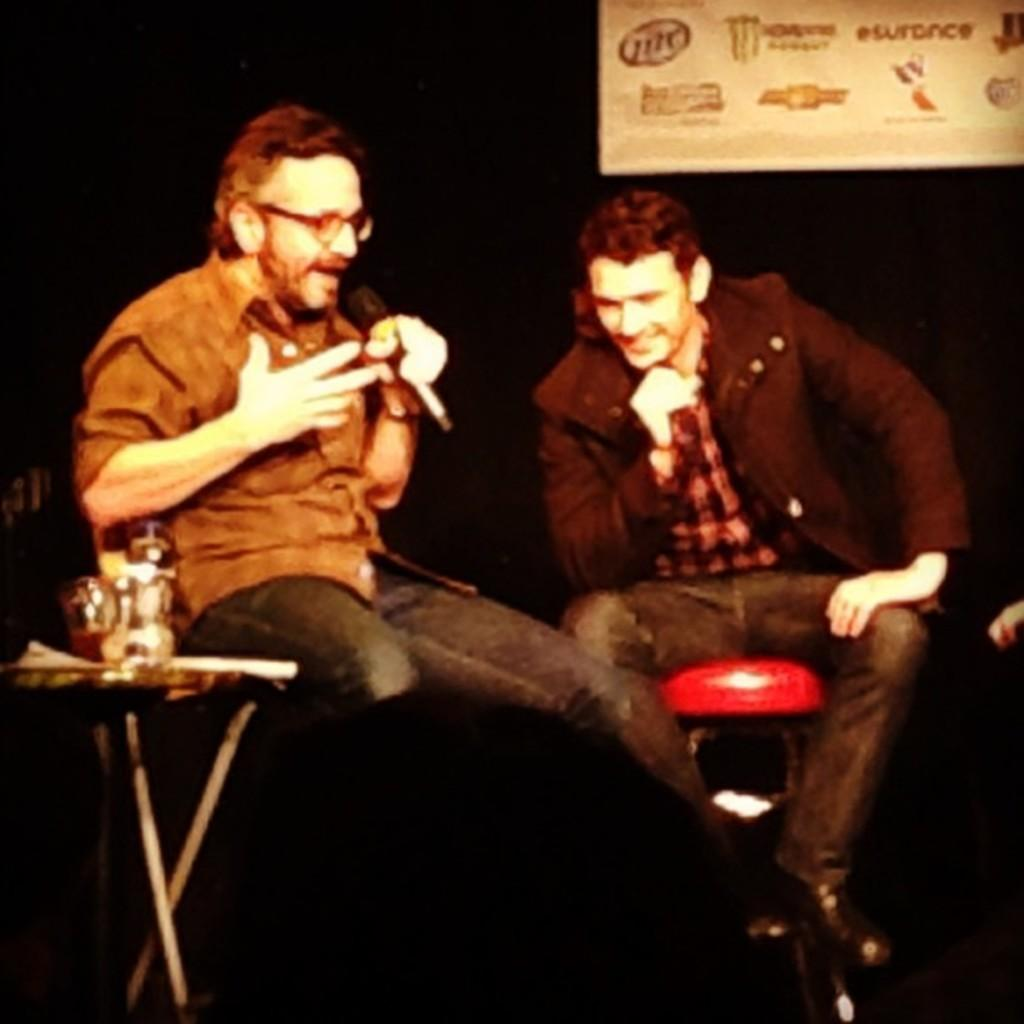How many people are in the image? There are two men in the image. What are the men doing in the image? The men are sitting on a table. Can you describe what one of the men is holding? One man is holding a microphone. What is one of the men doing in the image? One man is talking in the image. What type of hat is the bear wearing in the image? There are no bears or hats present in the image. How does the man solve the arithmetic problem while talking in the image? There is no arithmetic problem mentioned or depicted in the image. 